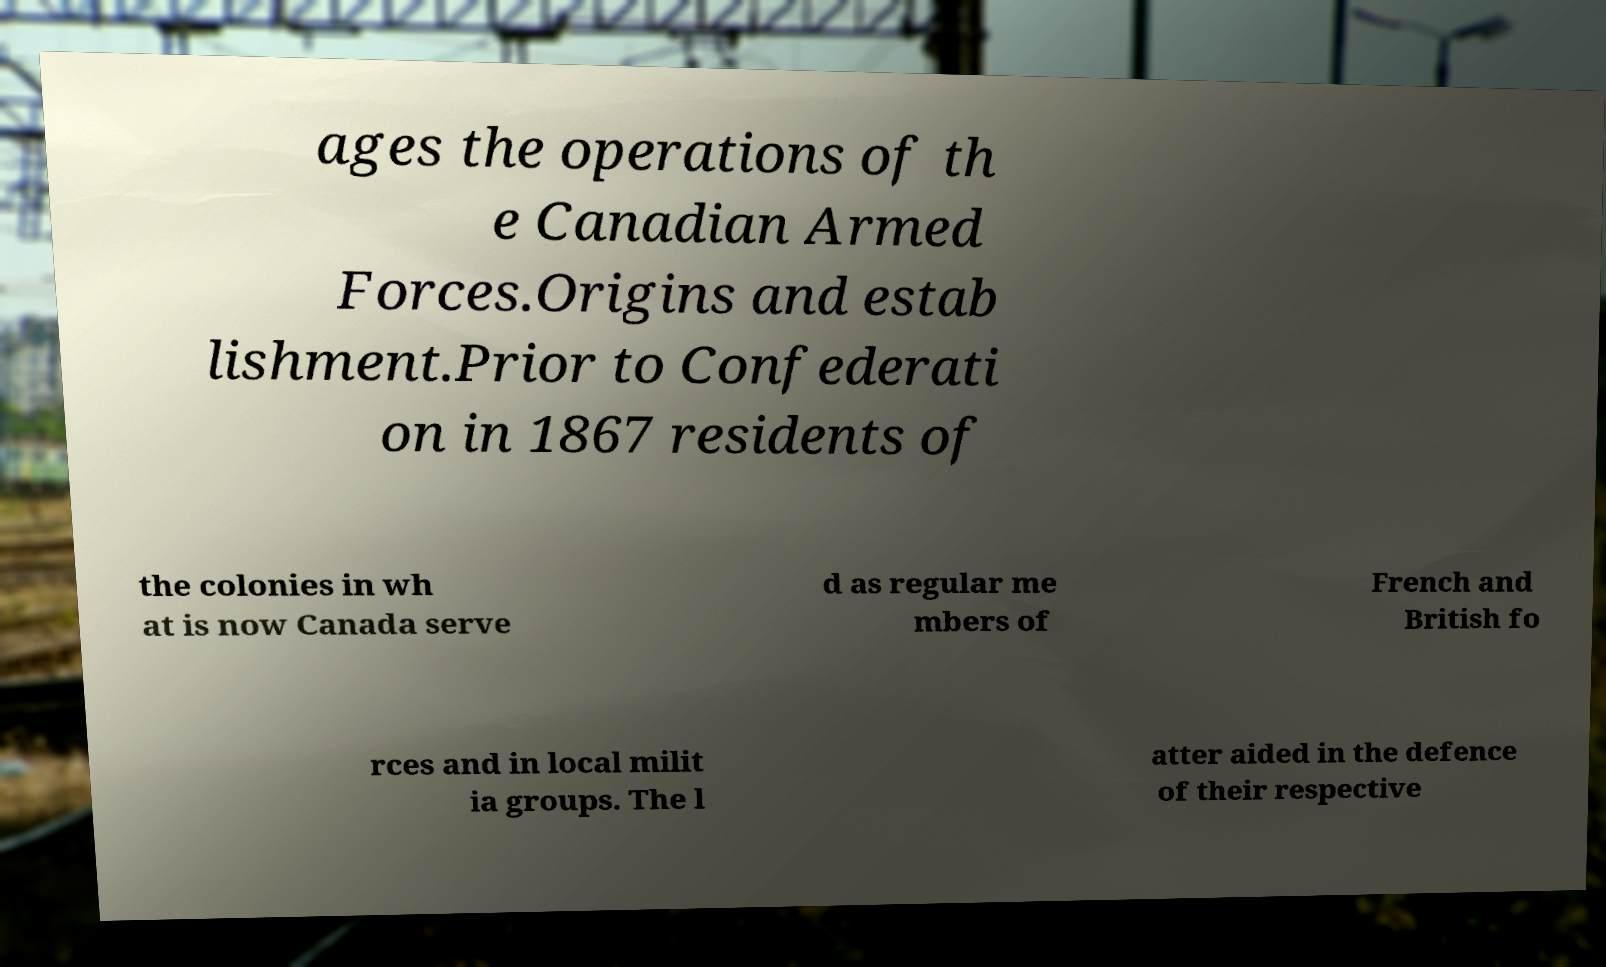Could you assist in decoding the text presented in this image and type it out clearly? ages the operations of th e Canadian Armed Forces.Origins and estab lishment.Prior to Confederati on in 1867 residents of the colonies in wh at is now Canada serve d as regular me mbers of French and British fo rces and in local milit ia groups. The l atter aided in the defence of their respective 